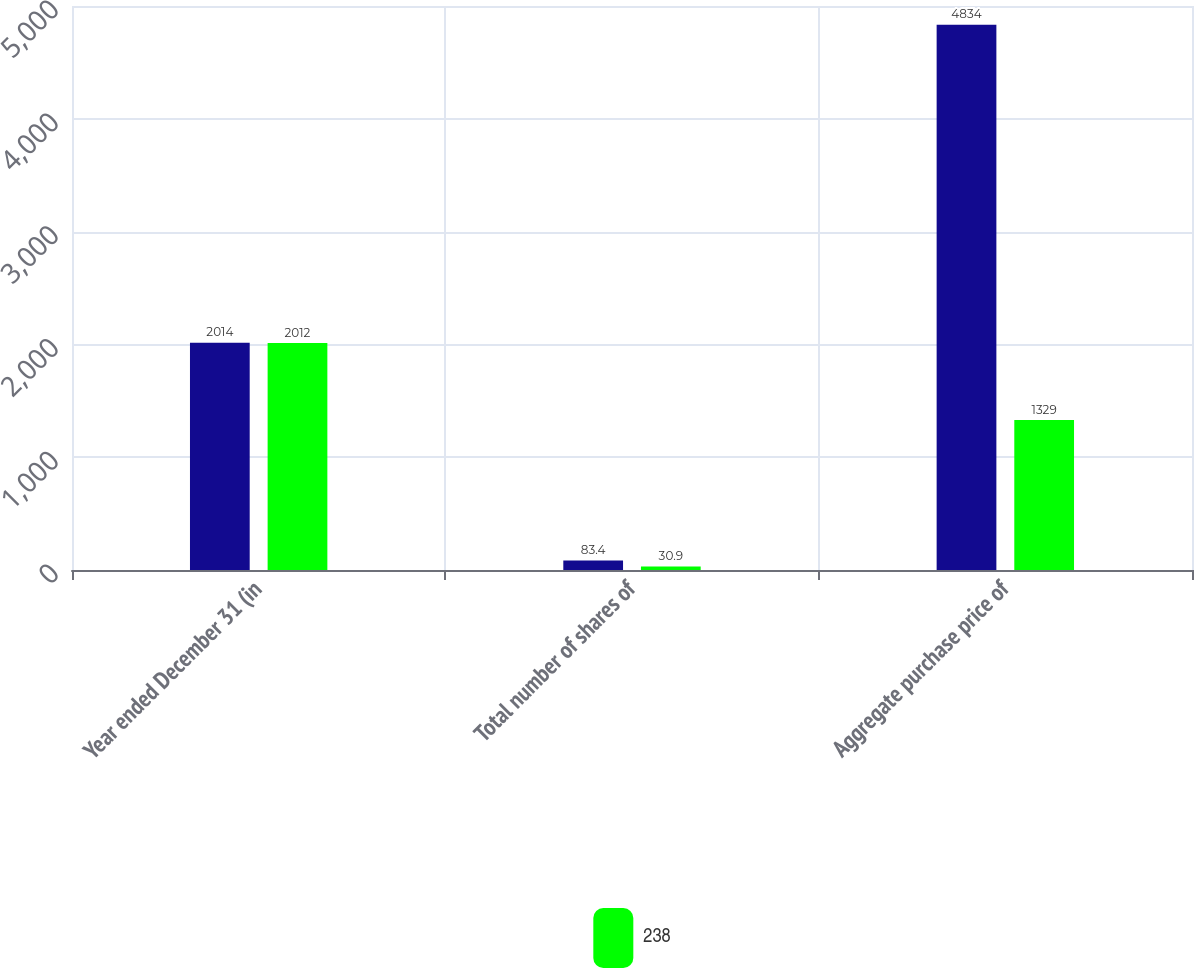Convert chart to OTSL. <chart><loc_0><loc_0><loc_500><loc_500><stacked_bar_chart><ecel><fcel>Year ended December 31 (in<fcel>Total number of shares of<fcel>Aggregate purchase price of<nl><fcel>nan<fcel>2014<fcel>83.4<fcel>4834<nl><fcel>238<fcel>2012<fcel>30.9<fcel>1329<nl></chart> 